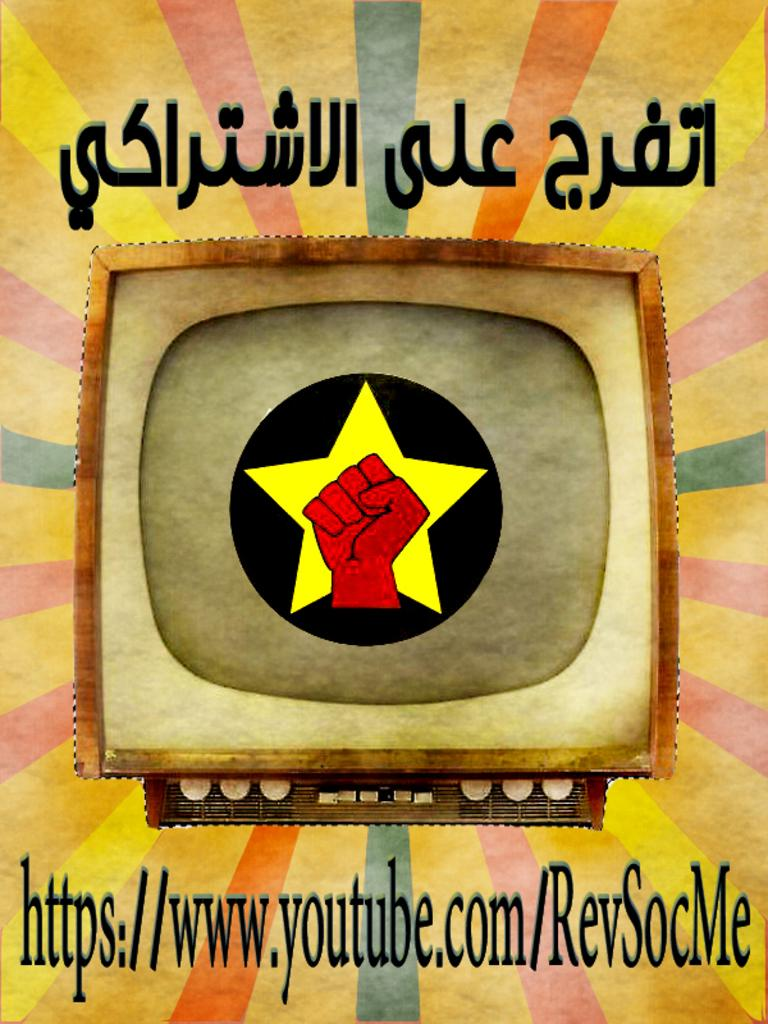<image>
Present a compact description of the photo's key features. An advertisement for a video on youtube showing a hand with a star around it on a television screen. 